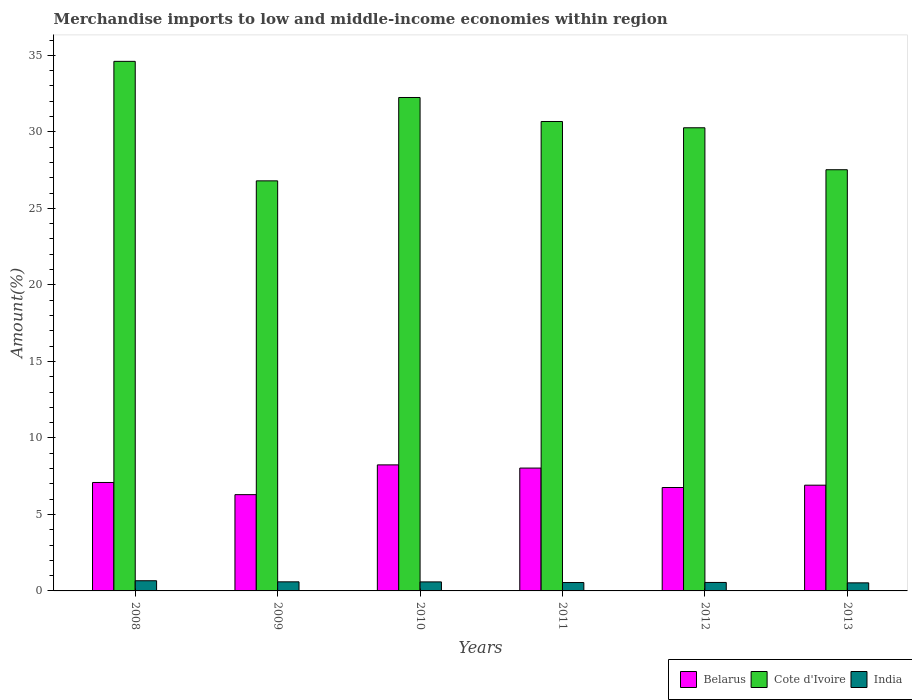Are the number of bars per tick equal to the number of legend labels?
Provide a short and direct response. Yes. How many bars are there on the 2nd tick from the left?
Your response must be concise. 3. How many bars are there on the 1st tick from the right?
Ensure brevity in your answer.  3. What is the percentage of amount earned from merchandise imports in India in 2010?
Offer a very short reply. 0.59. Across all years, what is the maximum percentage of amount earned from merchandise imports in Cote d'Ivoire?
Ensure brevity in your answer.  34.61. Across all years, what is the minimum percentage of amount earned from merchandise imports in Belarus?
Provide a succinct answer. 6.29. In which year was the percentage of amount earned from merchandise imports in Belarus minimum?
Give a very brief answer. 2009. What is the total percentage of amount earned from merchandise imports in Belarus in the graph?
Your answer should be very brief. 43.31. What is the difference between the percentage of amount earned from merchandise imports in Belarus in 2008 and that in 2013?
Keep it short and to the point. 0.18. What is the difference between the percentage of amount earned from merchandise imports in Cote d'Ivoire in 2008 and the percentage of amount earned from merchandise imports in Belarus in 2010?
Make the answer very short. 26.37. What is the average percentage of amount earned from merchandise imports in Cote d'Ivoire per year?
Your response must be concise. 30.36. In the year 2010, what is the difference between the percentage of amount earned from merchandise imports in Cote d'Ivoire and percentage of amount earned from merchandise imports in India?
Your response must be concise. 31.66. In how many years, is the percentage of amount earned from merchandise imports in India greater than 13 %?
Your response must be concise. 0. What is the ratio of the percentage of amount earned from merchandise imports in India in 2008 to that in 2010?
Offer a very short reply. 1.13. Is the percentage of amount earned from merchandise imports in India in 2011 less than that in 2013?
Provide a short and direct response. No. What is the difference between the highest and the second highest percentage of amount earned from merchandise imports in Belarus?
Provide a short and direct response. 0.21. What is the difference between the highest and the lowest percentage of amount earned from merchandise imports in Belarus?
Your answer should be very brief. 1.95. In how many years, is the percentage of amount earned from merchandise imports in Cote d'Ivoire greater than the average percentage of amount earned from merchandise imports in Cote d'Ivoire taken over all years?
Offer a terse response. 3. Is the sum of the percentage of amount earned from merchandise imports in India in 2010 and 2012 greater than the maximum percentage of amount earned from merchandise imports in Cote d'Ivoire across all years?
Your answer should be compact. No. What does the 1st bar from the left in 2008 represents?
Your answer should be compact. Belarus. What does the 3rd bar from the right in 2012 represents?
Ensure brevity in your answer.  Belarus. Is it the case that in every year, the sum of the percentage of amount earned from merchandise imports in India and percentage of amount earned from merchandise imports in Cote d'Ivoire is greater than the percentage of amount earned from merchandise imports in Belarus?
Offer a terse response. Yes. How many bars are there?
Ensure brevity in your answer.  18. Are all the bars in the graph horizontal?
Provide a succinct answer. No. Does the graph contain any zero values?
Offer a very short reply. No. Does the graph contain grids?
Provide a short and direct response. No. What is the title of the graph?
Keep it short and to the point. Merchandise imports to low and middle-income economies within region. Does "Belarus" appear as one of the legend labels in the graph?
Provide a succinct answer. Yes. What is the label or title of the Y-axis?
Offer a terse response. Amount(%). What is the Amount(%) of Belarus in 2008?
Your answer should be very brief. 7.09. What is the Amount(%) in Cote d'Ivoire in 2008?
Offer a terse response. 34.61. What is the Amount(%) of India in 2008?
Make the answer very short. 0.66. What is the Amount(%) in Belarus in 2009?
Keep it short and to the point. 6.29. What is the Amount(%) of Cote d'Ivoire in 2009?
Offer a terse response. 26.8. What is the Amount(%) of India in 2009?
Make the answer very short. 0.59. What is the Amount(%) of Belarus in 2010?
Provide a short and direct response. 8.24. What is the Amount(%) of Cote d'Ivoire in 2010?
Offer a very short reply. 32.25. What is the Amount(%) of India in 2010?
Offer a very short reply. 0.59. What is the Amount(%) in Belarus in 2011?
Offer a very short reply. 8.03. What is the Amount(%) in Cote d'Ivoire in 2011?
Your answer should be compact. 30.68. What is the Amount(%) of India in 2011?
Offer a terse response. 0.55. What is the Amount(%) in Belarus in 2012?
Offer a terse response. 6.76. What is the Amount(%) of Cote d'Ivoire in 2012?
Give a very brief answer. 30.27. What is the Amount(%) in India in 2012?
Provide a short and direct response. 0.55. What is the Amount(%) in Belarus in 2013?
Provide a short and direct response. 6.91. What is the Amount(%) of Cote d'Ivoire in 2013?
Provide a succinct answer. 27.53. What is the Amount(%) of India in 2013?
Your answer should be very brief. 0.53. Across all years, what is the maximum Amount(%) of Belarus?
Keep it short and to the point. 8.24. Across all years, what is the maximum Amount(%) of Cote d'Ivoire?
Offer a terse response. 34.61. Across all years, what is the maximum Amount(%) of India?
Your response must be concise. 0.66. Across all years, what is the minimum Amount(%) in Belarus?
Your answer should be compact. 6.29. Across all years, what is the minimum Amount(%) in Cote d'Ivoire?
Provide a short and direct response. 26.8. Across all years, what is the minimum Amount(%) of India?
Your answer should be very brief. 0.53. What is the total Amount(%) in Belarus in the graph?
Your response must be concise. 43.31. What is the total Amount(%) of Cote d'Ivoire in the graph?
Offer a terse response. 182.13. What is the total Amount(%) in India in the graph?
Your response must be concise. 3.48. What is the difference between the Amount(%) of Belarus in 2008 and that in 2009?
Keep it short and to the point. 0.8. What is the difference between the Amount(%) of Cote d'Ivoire in 2008 and that in 2009?
Make the answer very short. 7.81. What is the difference between the Amount(%) of India in 2008 and that in 2009?
Give a very brief answer. 0.07. What is the difference between the Amount(%) of Belarus in 2008 and that in 2010?
Provide a short and direct response. -1.15. What is the difference between the Amount(%) of Cote d'Ivoire in 2008 and that in 2010?
Ensure brevity in your answer.  2.36. What is the difference between the Amount(%) in India in 2008 and that in 2010?
Make the answer very short. 0.07. What is the difference between the Amount(%) in Belarus in 2008 and that in 2011?
Offer a terse response. -0.94. What is the difference between the Amount(%) of Cote d'Ivoire in 2008 and that in 2011?
Provide a short and direct response. 3.93. What is the difference between the Amount(%) in India in 2008 and that in 2011?
Your response must be concise. 0.12. What is the difference between the Amount(%) of Belarus in 2008 and that in 2012?
Your answer should be very brief. 0.33. What is the difference between the Amount(%) of Cote d'Ivoire in 2008 and that in 2012?
Keep it short and to the point. 4.34. What is the difference between the Amount(%) of Belarus in 2008 and that in 2013?
Provide a short and direct response. 0.18. What is the difference between the Amount(%) in Cote d'Ivoire in 2008 and that in 2013?
Keep it short and to the point. 7.08. What is the difference between the Amount(%) in India in 2008 and that in 2013?
Offer a terse response. 0.14. What is the difference between the Amount(%) of Belarus in 2009 and that in 2010?
Offer a terse response. -1.95. What is the difference between the Amount(%) in Cote d'Ivoire in 2009 and that in 2010?
Offer a very short reply. -5.45. What is the difference between the Amount(%) of India in 2009 and that in 2010?
Give a very brief answer. 0. What is the difference between the Amount(%) in Belarus in 2009 and that in 2011?
Offer a terse response. -1.74. What is the difference between the Amount(%) in Cote d'Ivoire in 2009 and that in 2011?
Your response must be concise. -3.88. What is the difference between the Amount(%) of India in 2009 and that in 2011?
Give a very brief answer. 0.05. What is the difference between the Amount(%) in Belarus in 2009 and that in 2012?
Ensure brevity in your answer.  -0.47. What is the difference between the Amount(%) of Cote d'Ivoire in 2009 and that in 2012?
Your response must be concise. -3.47. What is the difference between the Amount(%) in India in 2009 and that in 2012?
Make the answer very short. 0.04. What is the difference between the Amount(%) of Belarus in 2009 and that in 2013?
Ensure brevity in your answer.  -0.62. What is the difference between the Amount(%) of Cote d'Ivoire in 2009 and that in 2013?
Give a very brief answer. -0.73. What is the difference between the Amount(%) of India in 2009 and that in 2013?
Your response must be concise. 0.07. What is the difference between the Amount(%) in Belarus in 2010 and that in 2011?
Ensure brevity in your answer.  0.21. What is the difference between the Amount(%) in Cote d'Ivoire in 2010 and that in 2011?
Your response must be concise. 1.57. What is the difference between the Amount(%) of India in 2010 and that in 2011?
Give a very brief answer. 0.04. What is the difference between the Amount(%) in Belarus in 2010 and that in 2012?
Your answer should be compact. 1.48. What is the difference between the Amount(%) of Cote d'Ivoire in 2010 and that in 2012?
Your response must be concise. 1.98. What is the difference between the Amount(%) of India in 2010 and that in 2012?
Offer a very short reply. 0.04. What is the difference between the Amount(%) in Belarus in 2010 and that in 2013?
Offer a very short reply. 1.33. What is the difference between the Amount(%) of Cote d'Ivoire in 2010 and that in 2013?
Offer a very short reply. 4.72. What is the difference between the Amount(%) in India in 2010 and that in 2013?
Offer a terse response. 0.06. What is the difference between the Amount(%) in Belarus in 2011 and that in 2012?
Offer a very short reply. 1.27. What is the difference between the Amount(%) in Cote d'Ivoire in 2011 and that in 2012?
Provide a succinct answer. 0.41. What is the difference between the Amount(%) of India in 2011 and that in 2012?
Give a very brief answer. -0.01. What is the difference between the Amount(%) of Belarus in 2011 and that in 2013?
Your response must be concise. 1.12. What is the difference between the Amount(%) in Cote d'Ivoire in 2011 and that in 2013?
Your answer should be compact. 3.15. What is the difference between the Amount(%) of India in 2011 and that in 2013?
Your answer should be very brief. 0.02. What is the difference between the Amount(%) in Belarus in 2012 and that in 2013?
Make the answer very short. -0.15. What is the difference between the Amount(%) in Cote d'Ivoire in 2012 and that in 2013?
Make the answer very short. 2.74. What is the difference between the Amount(%) of India in 2012 and that in 2013?
Ensure brevity in your answer.  0.03. What is the difference between the Amount(%) in Belarus in 2008 and the Amount(%) in Cote d'Ivoire in 2009?
Your response must be concise. -19.71. What is the difference between the Amount(%) of Belarus in 2008 and the Amount(%) of India in 2009?
Your answer should be very brief. 6.49. What is the difference between the Amount(%) of Cote d'Ivoire in 2008 and the Amount(%) of India in 2009?
Provide a succinct answer. 34.02. What is the difference between the Amount(%) in Belarus in 2008 and the Amount(%) in Cote d'Ivoire in 2010?
Your response must be concise. -25.16. What is the difference between the Amount(%) of Belarus in 2008 and the Amount(%) of India in 2010?
Provide a succinct answer. 6.5. What is the difference between the Amount(%) of Cote d'Ivoire in 2008 and the Amount(%) of India in 2010?
Make the answer very short. 34.02. What is the difference between the Amount(%) in Belarus in 2008 and the Amount(%) in Cote d'Ivoire in 2011?
Your answer should be compact. -23.59. What is the difference between the Amount(%) of Belarus in 2008 and the Amount(%) of India in 2011?
Provide a succinct answer. 6.54. What is the difference between the Amount(%) of Cote d'Ivoire in 2008 and the Amount(%) of India in 2011?
Make the answer very short. 34.06. What is the difference between the Amount(%) in Belarus in 2008 and the Amount(%) in Cote d'Ivoire in 2012?
Your answer should be compact. -23.18. What is the difference between the Amount(%) in Belarus in 2008 and the Amount(%) in India in 2012?
Make the answer very short. 6.53. What is the difference between the Amount(%) of Cote d'Ivoire in 2008 and the Amount(%) of India in 2012?
Keep it short and to the point. 34.06. What is the difference between the Amount(%) of Belarus in 2008 and the Amount(%) of Cote d'Ivoire in 2013?
Provide a short and direct response. -20.44. What is the difference between the Amount(%) of Belarus in 2008 and the Amount(%) of India in 2013?
Your answer should be very brief. 6.56. What is the difference between the Amount(%) of Cote d'Ivoire in 2008 and the Amount(%) of India in 2013?
Your answer should be very brief. 34.08. What is the difference between the Amount(%) in Belarus in 2009 and the Amount(%) in Cote d'Ivoire in 2010?
Offer a very short reply. -25.96. What is the difference between the Amount(%) of Belarus in 2009 and the Amount(%) of India in 2010?
Your answer should be very brief. 5.7. What is the difference between the Amount(%) in Cote d'Ivoire in 2009 and the Amount(%) in India in 2010?
Keep it short and to the point. 26.21. What is the difference between the Amount(%) in Belarus in 2009 and the Amount(%) in Cote d'Ivoire in 2011?
Keep it short and to the point. -24.39. What is the difference between the Amount(%) of Belarus in 2009 and the Amount(%) of India in 2011?
Your answer should be compact. 5.74. What is the difference between the Amount(%) of Cote d'Ivoire in 2009 and the Amount(%) of India in 2011?
Offer a terse response. 26.25. What is the difference between the Amount(%) of Belarus in 2009 and the Amount(%) of Cote d'Ivoire in 2012?
Provide a short and direct response. -23.98. What is the difference between the Amount(%) of Belarus in 2009 and the Amount(%) of India in 2012?
Keep it short and to the point. 5.74. What is the difference between the Amount(%) of Cote d'Ivoire in 2009 and the Amount(%) of India in 2012?
Offer a terse response. 26.25. What is the difference between the Amount(%) of Belarus in 2009 and the Amount(%) of Cote d'Ivoire in 2013?
Keep it short and to the point. -21.24. What is the difference between the Amount(%) of Belarus in 2009 and the Amount(%) of India in 2013?
Ensure brevity in your answer.  5.76. What is the difference between the Amount(%) of Cote d'Ivoire in 2009 and the Amount(%) of India in 2013?
Ensure brevity in your answer.  26.27. What is the difference between the Amount(%) of Belarus in 2010 and the Amount(%) of Cote d'Ivoire in 2011?
Your answer should be compact. -22.44. What is the difference between the Amount(%) of Belarus in 2010 and the Amount(%) of India in 2011?
Ensure brevity in your answer.  7.69. What is the difference between the Amount(%) of Cote d'Ivoire in 2010 and the Amount(%) of India in 2011?
Ensure brevity in your answer.  31.7. What is the difference between the Amount(%) of Belarus in 2010 and the Amount(%) of Cote d'Ivoire in 2012?
Provide a short and direct response. -22.03. What is the difference between the Amount(%) in Belarus in 2010 and the Amount(%) in India in 2012?
Keep it short and to the point. 7.68. What is the difference between the Amount(%) of Cote d'Ivoire in 2010 and the Amount(%) of India in 2012?
Offer a very short reply. 31.69. What is the difference between the Amount(%) in Belarus in 2010 and the Amount(%) in Cote d'Ivoire in 2013?
Your answer should be compact. -19.29. What is the difference between the Amount(%) in Belarus in 2010 and the Amount(%) in India in 2013?
Ensure brevity in your answer.  7.71. What is the difference between the Amount(%) in Cote d'Ivoire in 2010 and the Amount(%) in India in 2013?
Make the answer very short. 31.72. What is the difference between the Amount(%) of Belarus in 2011 and the Amount(%) of Cote d'Ivoire in 2012?
Your answer should be very brief. -22.24. What is the difference between the Amount(%) of Belarus in 2011 and the Amount(%) of India in 2012?
Keep it short and to the point. 7.47. What is the difference between the Amount(%) in Cote d'Ivoire in 2011 and the Amount(%) in India in 2012?
Offer a very short reply. 30.13. What is the difference between the Amount(%) in Belarus in 2011 and the Amount(%) in Cote d'Ivoire in 2013?
Your answer should be compact. -19.5. What is the difference between the Amount(%) of Belarus in 2011 and the Amount(%) of India in 2013?
Offer a very short reply. 7.5. What is the difference between the Amount(%) in Cote d'Ivoire in 2011 and the Amount(%) in India in 2013?
Give a very brief answer. 30.15. What is the difference between the Amount(%) in Belarus in 2012 and the Amount(%) in Cote d'Ivoire in 2013?
Make the answer very short. -20.77. What is the difference between the Amount(%) of Belarus in 2012 and the Amount(%) of India in 2013?
Provide a succinct answer. 6.23. What is the difference between the Amount(%) of Cote d'Ivoire in 2012 and the Amount(%) of India in 2013?
Your answer should be compact. 29.74. What is the average Amount(%) in Belarus per year?
Offer a very short reply. 7.22. What is the average Amount(%) in Cote d'Ivoire per year?
Your answer should be compact. 30.36. What is the average Amount(%) in India per year?
Give a very brief answer. 0.58. In the year 2008, what is the difference between the Amount(%) in Belarus and Amount(%) in Cote d'Ivoire?
Make the answer very short. -27.52. In the year 2008, what is the difference between the Amount(%) in Belarus and Amount(%) in India?
Your answer should be very brief. 6.42. In the year 2008, what is the difference between the Amount(%) of Cote d'Ivoire and Amount(%) of India?
Offer a terse response. 33.94. In the year 2009, what is the difference between the Amount(%) of Belarus and Amount(%) of Cote d'Ivoire?
Your answer should be very brief. -20.51. In the year 2009, what is the difference between the Amount(%) in Belarus and Amount(%) in India?
Make the answer very short. 5.7. In the year 2009, what is the difference between the Amount(%) of Cote d'Ivoire and Amount(%) of India?
Your response must be concise. 26.21. In the year 2010, what is the difference between the Amount(%) in Belarus and Amount(%) in Cote d'Ivoire?
Your answer should be very brief. -24.01. In the year 2010, what is the difference between the Amount(%) of Belarus and Amount(%) of India?
Make the answer very short. 7.65. In the year 2010, what is the difference between the Amount(%) in Cote d'Ivoire and Amount(%) in India?
Your answer should be compact. 31.66. In the year 2011, what is the difference between the Amount(%) of Belarus and Amount(%) of Cote d'Ivoire?
Offer a very short reply. -22.65. In the year 2011, what is the difference between the Amount(%) of Belarus and Amount(%) of India?
Provide a succinct answer. 7.48. In the year 2011, what is the difference between the Amount(%) of Cote d'Ivoire and Amount(%) of India?
Make the answer very short. 30.13. In the year 2012, what is the difference between the Amount(%) in Belarus and Amount(%) in Cote d'Ivoire?
Your answer should be compact. -23.51. In the year 2012, what is the difference between the Amount(%) in Belarus and Amount(%) in India?
Offer a very short reply. 6.21. In the year 2012, what is the difference between the Amount(%) of Cote d'Ivoire and Amount(%) of India?
Ensure brevity in your answer.  29.72. In the year 2013, what is the difference between the Amount(%) in Belarus and Amount(%) in Cote d'Ivoire?
Make the answer very short. -20.62. In the year 2013, what is the difference between the Amount(%) in Belarus and Amount(%) in India?
Offer a very short reply. 6.38. In the year 2013, what is the difference between the Amount(%) in Cote d'Ivoire and Amount(%) in India?
Offer a very short reply. 27. What is the ratio of the Amount(%) of Belarus in 2008 to that in 2009?
Offer a terse response. 1.13. What is the ratio of the Amount(%) of Cote d'Ivoire in 2008 to that in 2009?
Offer a terse response. 1.29. What is the ratio of the Amount(%) in India in 2008 to that in 2009?
Your response must be concise. 1.12. What is the ratio of the Amount(%) in Belarus in 2008 to that in 2010?
Keep it short and to the point. 0.86. What is the ratio of the Amount(%) of Cote d'Ivoire in 2008 to that in 2010?
Your answer should be very brief. 1.07. What is the ratio of the Amount(%) in India in 2008 to that in 2010?
Provide a succinct answer. 1.13. What is the ratio of the Amount(%) in Belarus in 2008 to that in 2011?
Give a very brief answer. 0.88. What is the ratio of the Amount(%) in Cote d'Ivoire in 2008 to that in 2011?
Make the answer very short. 1.13. What is the ratio of the Amount(%) in India in 2008 to that in 2011?
Ensure brevity in your answer.  1.21. What is the ratio of the Amount(%) of Belarus in 2008 to that in 2012?
Offer a terse response. 1.05. What is the ratio of the Amount(%) of Cote d'Ivoire in 2008 to that in 2012?
Your answer should be compact. 1.14. What is the ratio of the Amount(%) in India in 2008 to that in 2012?
Ensure brevity in your answer.  1.2. What is the ratio of the Amount(%) of Belarus in 2008 to that in 2013?
Provide a succinct answer. 1.03. What is the ratio of the Amount(%) in Cote d'Ivoire in 2008 to that in 2013?
Your response must be concise. 1.26. What is the ratio of the Amount(%) in India in 2008 to that in 2013?
Provide a short and direct response. 1.26. What is the ratio of the Amount(%) in Belarus in 2009 to that in 2010?
Your answer should be very brief. 0.76. What is the ratio of the Amount(%) of Cote d'Ivoire in 2009 to that in 2010?
Give a very brief answer. 0.83. What is the ratio of the Amount(%) in India in 2009 to that in 2010?
Give a very brief answer. 1.01. What is the ratio of the Amount(%) of Belarus in 2009 to that in 2011?
Ensure brevity in your answer.  0.78. What is the ratio of the Amount(%) in Cote d'Ivoire in 2009 to that in 2011?
Offer a very short reply. 0.87. What is the ratio of the Amount(%) of India in 2009 to that in 2011?
Offer a terse response. 1.08. What is the ratio of the Amount(%) in Belarus in 2009 to that in 2012?
Your answer should be very brief. 0.93. What is the ratio of the Amount(%) in Cote d'Ivoire in 2009 to that in 2012?
Your response must be concise. 0.89. What is the ratio of the Amount(%) in India in 2009 to that in 2012?
Offer a terse response. 1.07. What is the ratio of the Amount(%) in Belarus in 2009 to that in 2013?
Your answer should be very brief. 0.91. What is the ratio of the Amount(%) in Cote d'Ivoire in 2009 to that in 2013?
Make the answer very short. 0.97. What is the ratio of the Amount(%) in India in 2009 to that in 2013?
Ensure brevity in your answer.  1.13. What is the ratio of the Amount(%) of Belarus in 2010 to that in 2011?
Provide a succinct answer. 1.03. What is the ratio of the Amount(%) of Cote d'Ivoire in 2010 to that in 2011?
Offer a very short reply. 1.05. What is the ratio of the Amount(%) in India in 2010 to that in 2011?
Give a very brief answer. 1.08. What is the ratio of the Amount(%) of Belarus in 2010 to that in 2012?
Make the answer very short. 1.22. What is the ratio of the Amount(%) of Cote d'Ivoire in 2010 to that in 2012?
Give a very brief answer. 1.07. What is the ratio of the Amount(%) of India in 2010 to that in 2012?
Your answer should be compact. 1.07. What is the ratio of the Amount(%) in Belarus in 2010 to that in 2013?
Your answer should be compact. 1.19. What is the ratio of the Amount(%) in Cote d'Ivoire in 2010 to that in 2013?
Make the answer very short. 1.17. What is the ratio of the Amount(%) of India in 2010 to that in 2013?
Ensure brevity in your answer.  1.12. What is the ratio of the Amount(%) in Belarus in 2011 to that in 2012?
Your answer should be compact. 1.19. What is the ratio of the Amount(%) in Cote d'Ivoire in 2011 to that in 2012?
Provide a short and direct response. 1.01. What is the ratio of the Amount(%) in India in 2011 to that in 2012?
Your response must be concise. 0.99. What is the ratio of the Amount(%) in Belarus in 2011 to that in 2013?
Your answer should be very brief. 1.16. What is the ratio of the Amount(%) of Cote d'Ivoire in 2011 to that in 2013?
Your answer should be very brief. 1.11. What is the ratio of the Amount(%) of India in 2011 to that in 2013?
Your response must be concise. 1.04. What is the ratio of the Amount(%) in Belarus in 2012 to that in 2013?
Your response must be concise. 0.98. What is the ratio of the Amount(%) of Cote d'Ivoire in 2012 to that in 2013?
Offer a terse response. 1.1. What is the ratio of the Amount(%) in India in 2012 to that in 2013?
Provide a succinct answer. 1.05. What is the difference between the highest and the second highest Amount(%) in Belarus?
Your response must be concise. 0.21. What is the difference between the highest and the second highest Amount(%) in Cote d'Ivoire?
Your answer should be very brief. 2.36. What is the difference between the highest and the second highest Amount(%) of India?
Make the answer very short. 0.07. What is the difference between the highest and the lowest Amount(%) in Belarus?
Provide a short and direct response. 1.95. What is the difference between the highest and the lowest Amount(%) in Cote d'Ivoire?
Your answer should be compact. 7.81. What is the difference between the highest and the lowest Amount(%) in India?
Offer a very short reply. 0.14. 